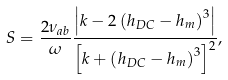Convert formula to latex. <formula><loc_0><loc_0><loc_500><loc_500>S = \frac { 2 \nu _ { a b } } { \omega } \frac { \left | k - 2 \left ( h _ { D C } - h _ { m } \right ) ^ { 3 } \right | } { \left [ k + \left ( h _ { D C } - h _ { m } \right ) ^ { 3 } \right ] ^ { 2 } } ,</formula> 